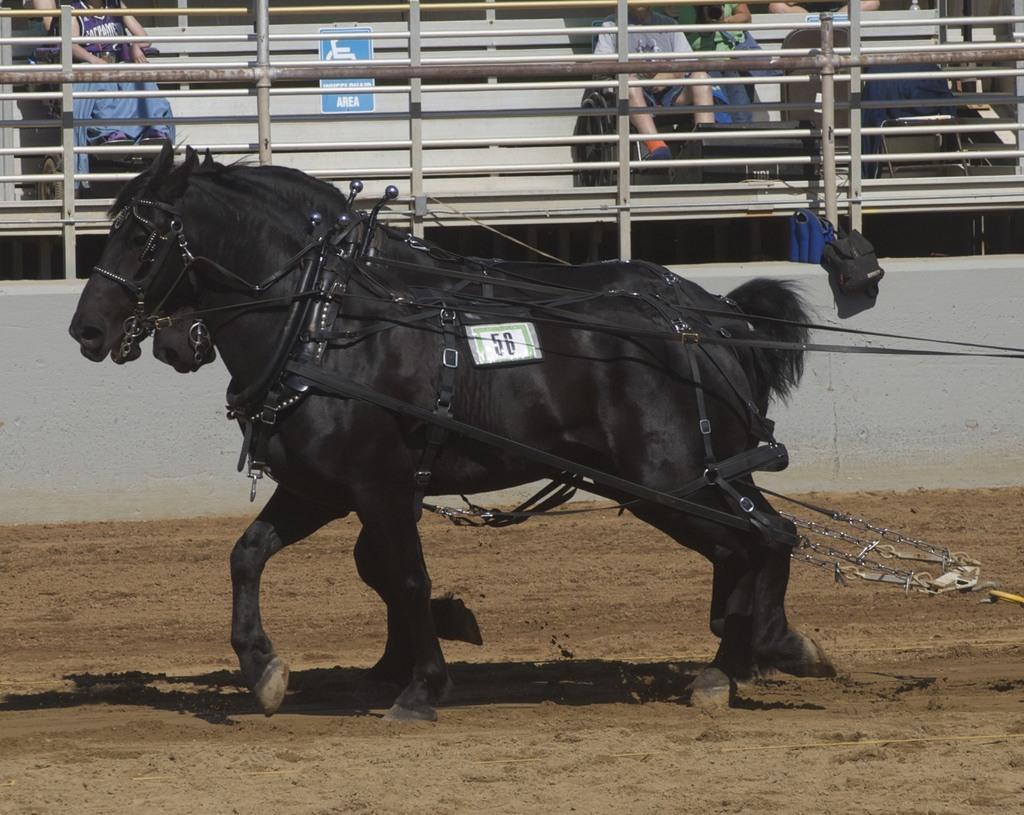Could you give a brief overview of what you see in this image? In this picture I can see black color horses. On these horses I can see some objects attached to them. In the background I can see a fence and people. 